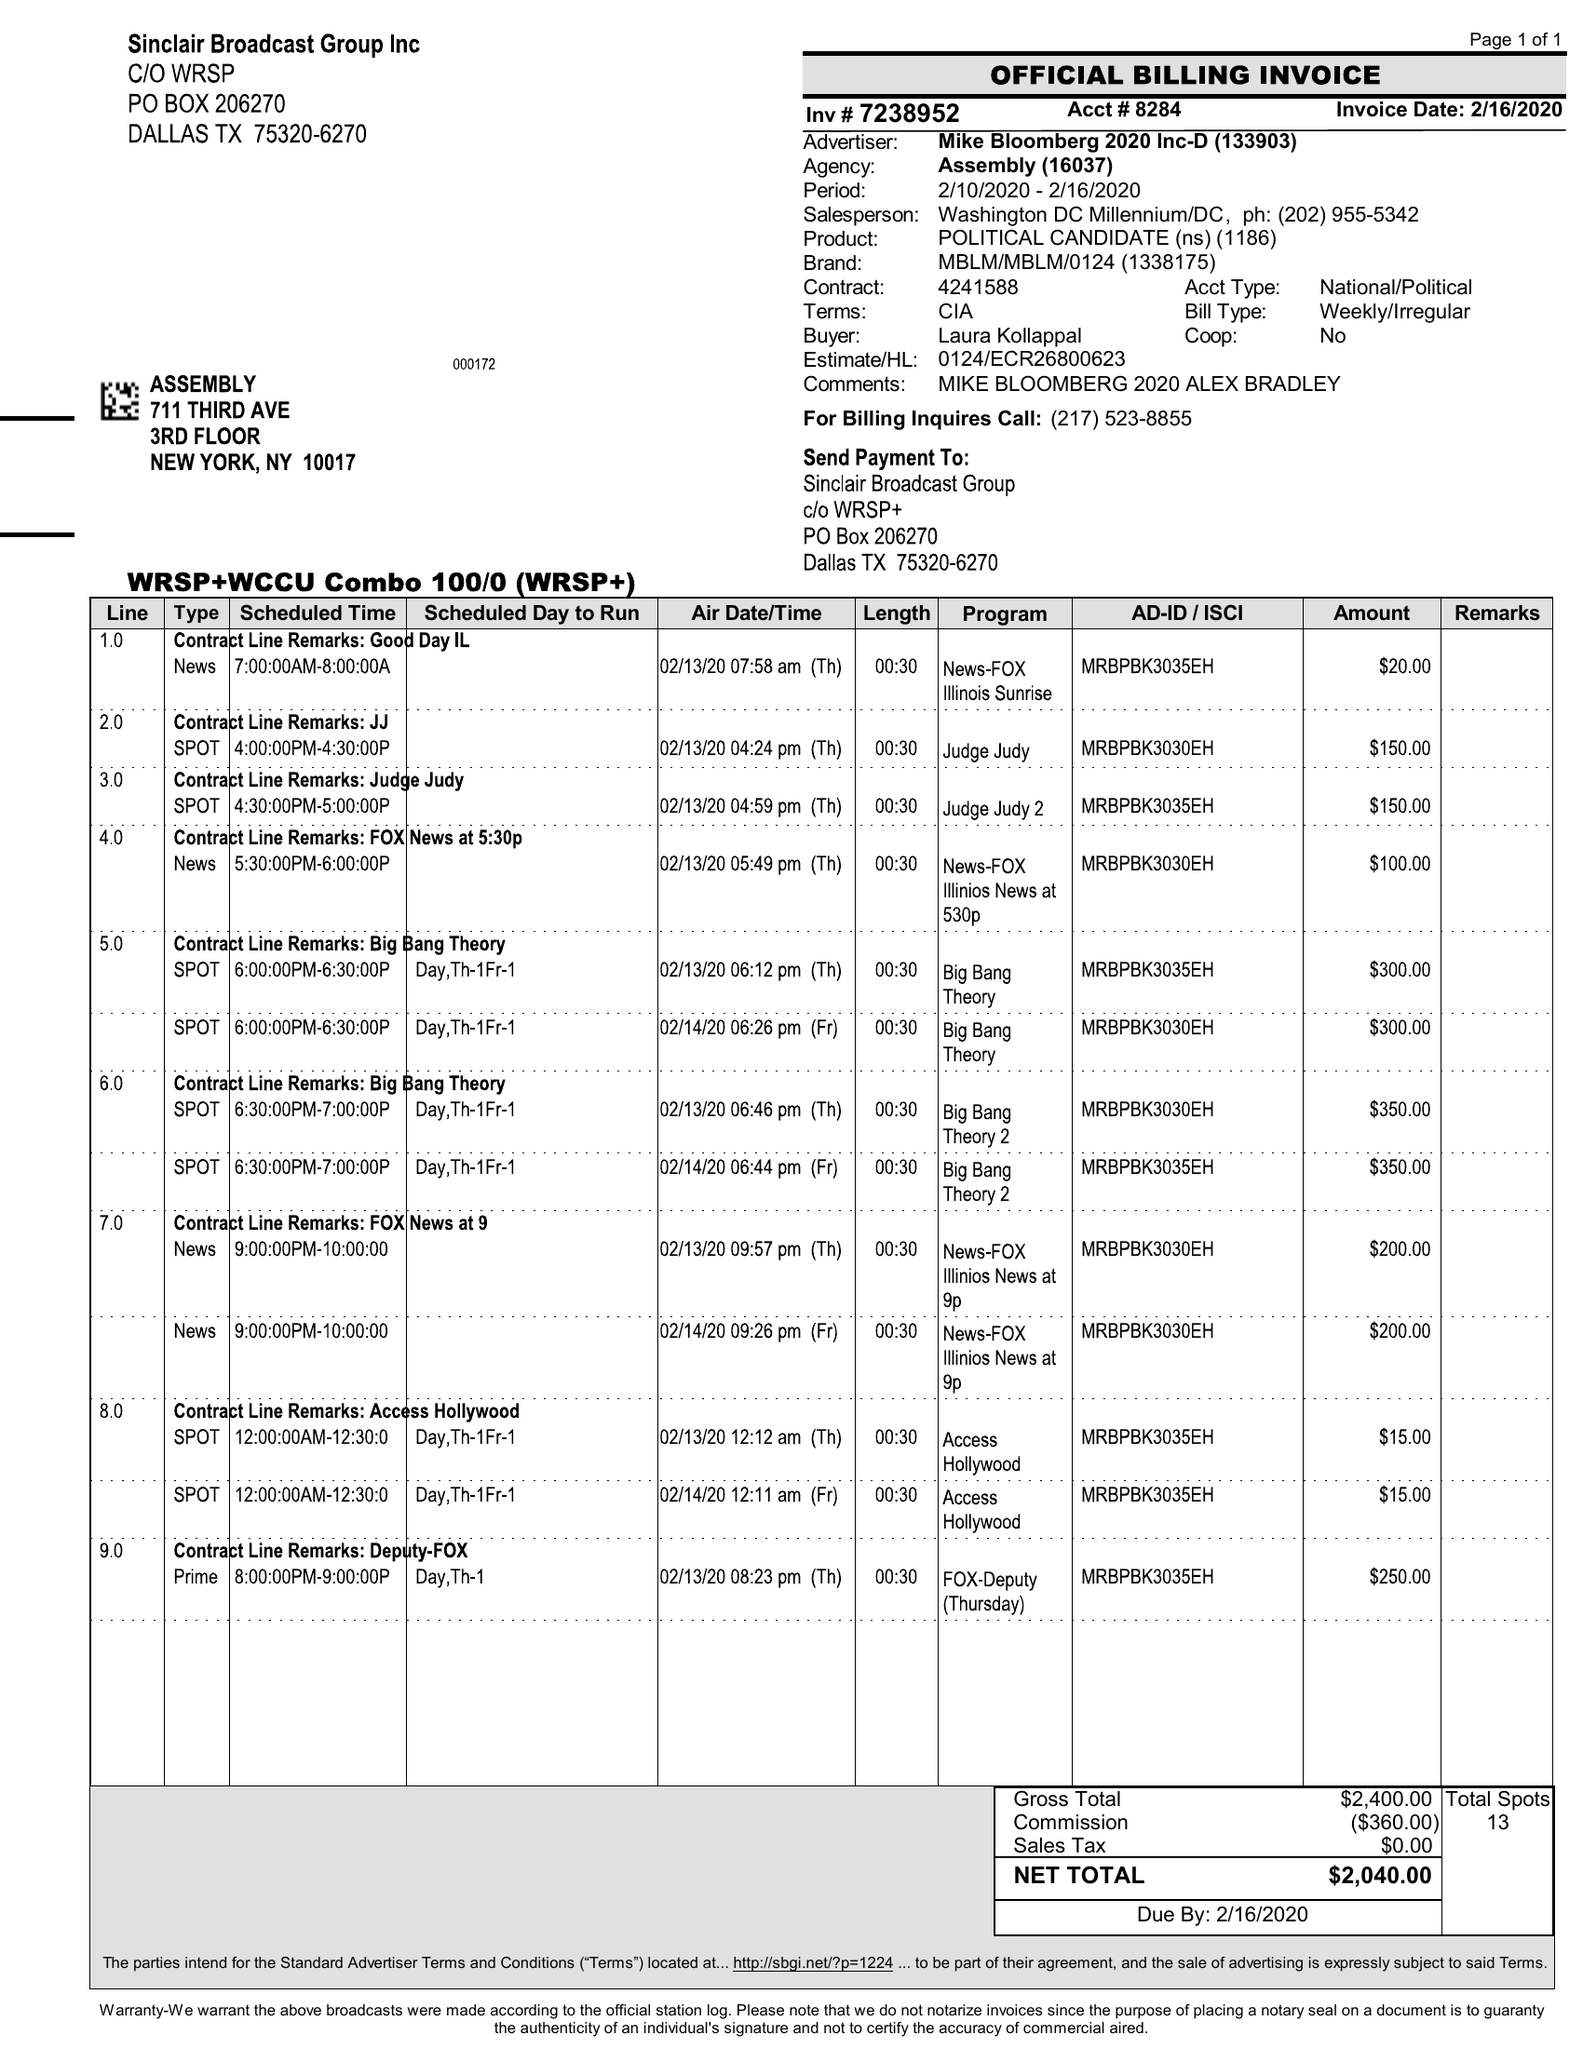What is the value for the advertiser?
Answer the question using a single word or phrase. MIKE BLOOMBERG 2020 INC-D 